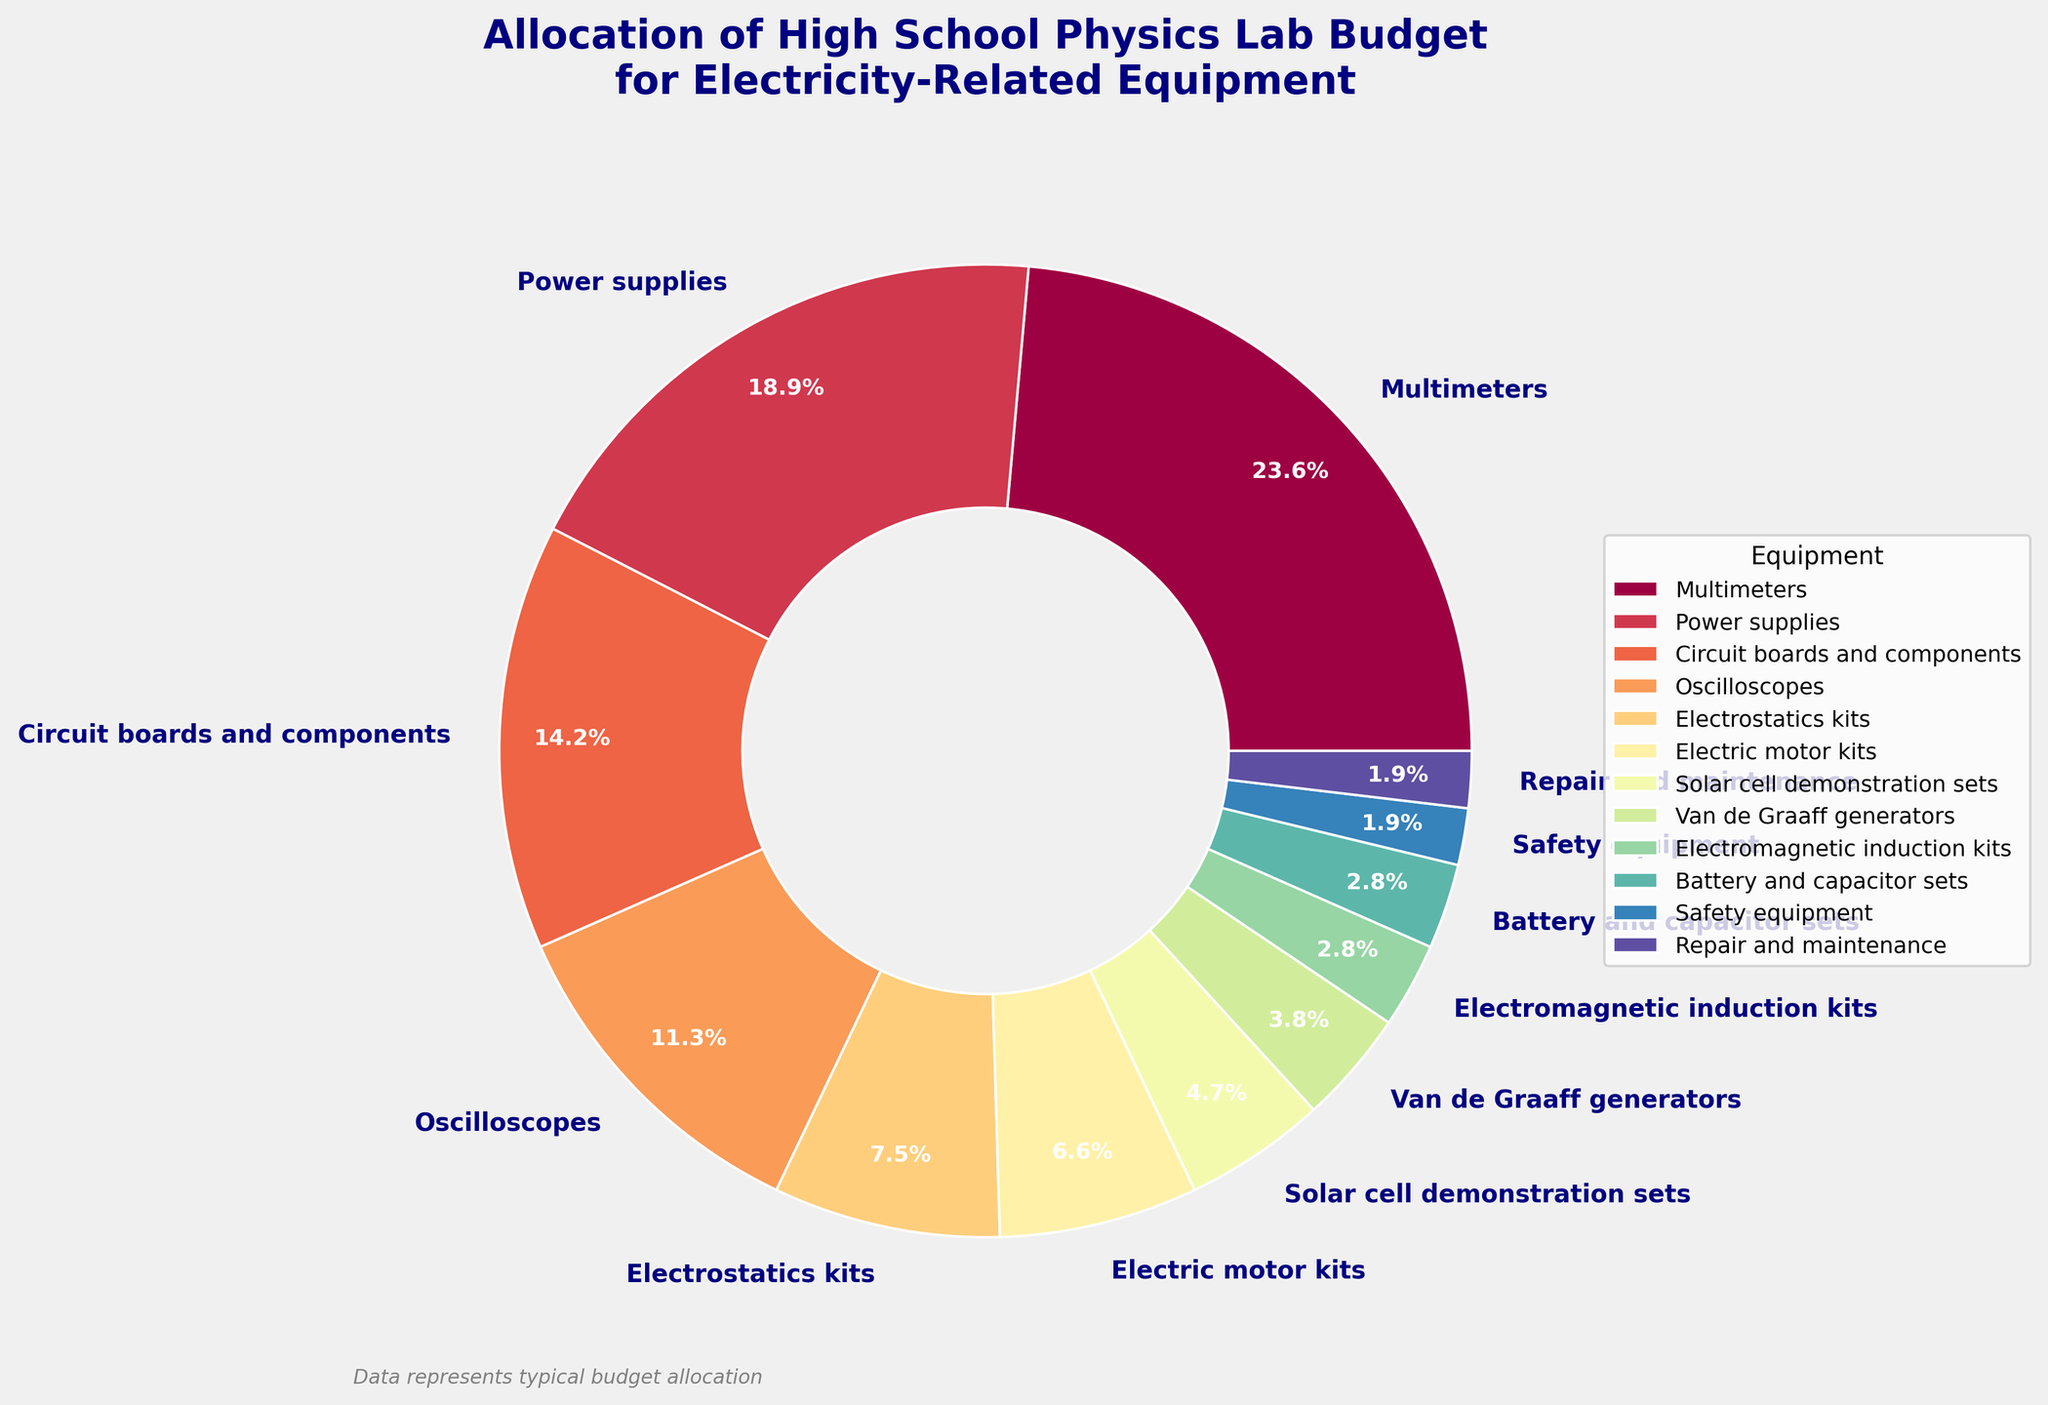What equipment category has the largest allocation of the budget? The pie chart shows the equipment categories and their respective percentages. The largest section is for Multimeters, which takes up 25% of the budget.
Answer: Multimeters How much more of the budget is allocated to Power supplies compared to Solar cell demonstration sets? Power supplies are allocated 20% of the budget while Solar cell demonstration sets are allocated 5%. The difference is 20% - 5% = 15%.
Answer: 15% What is the combined budget allocation for Circuit boards and components, and Oscilloscopes? Circuit boards and components have 15%, and Oscilloscopes have 12%. The combined allocation is 15% + 12% = 27%.
Answer: 27% Which equipment has a smaller budget allocation, Electrostatics kits or Van de Graaff generators? The pie chart shows that Electrostatics kits have an 8% allocation, while Van de Graaff generators have a 4% allocation.
Answer: Van de Graaff generators Are there more funds allocated to Electric motor kits or Battery and capacitor sets? Electric motor kits are allocated 7% of the budget, whereas Battery and capacitor sets are allocated 3%. Therefore, more funds are allocated to Electric motor kits.
Answer: Electric motor kits What is the total percentage of the budget allocated to items with an allocation less than 5%? The items with less than 5% are Van de Graaff generators (4%), Electromagnetic induction kits (3%), Battery and capacitor sets (3%), Safety equipment (2%), and Repair and maintenance (2%). Adding these percentages: 4% + 3% + 3% + 2% + 2% = 14%.
Answer: 14% How does the budget allocation for Oscilloscopes compare with that for Multimeters in terms of their ratio? Oscilloscopes have 12% allocation, and Multimeters have 25%. The ratio of Oscilloscopes to Multimeters is 12:25 or simplified to about 0.48 when converted to decimal form.
Answer: 0.48 What percentage of the budget is allocated to less expensive equipment (those below 10%)? Equipments below 10% are Electrostatics kits (8%), Electric motor kits (7%), Solar cell demonstration sets (5%), Van de Graaff generators (4%), Electromagnetic induction kits (3%), Battery and capacitor sets (3%), Safety equipment (2%), and Repair and maintenance (2%). Their sum is 8%+7%+5%+4%+3%+3%+2%+2% = 34%.
Answer: 34% 